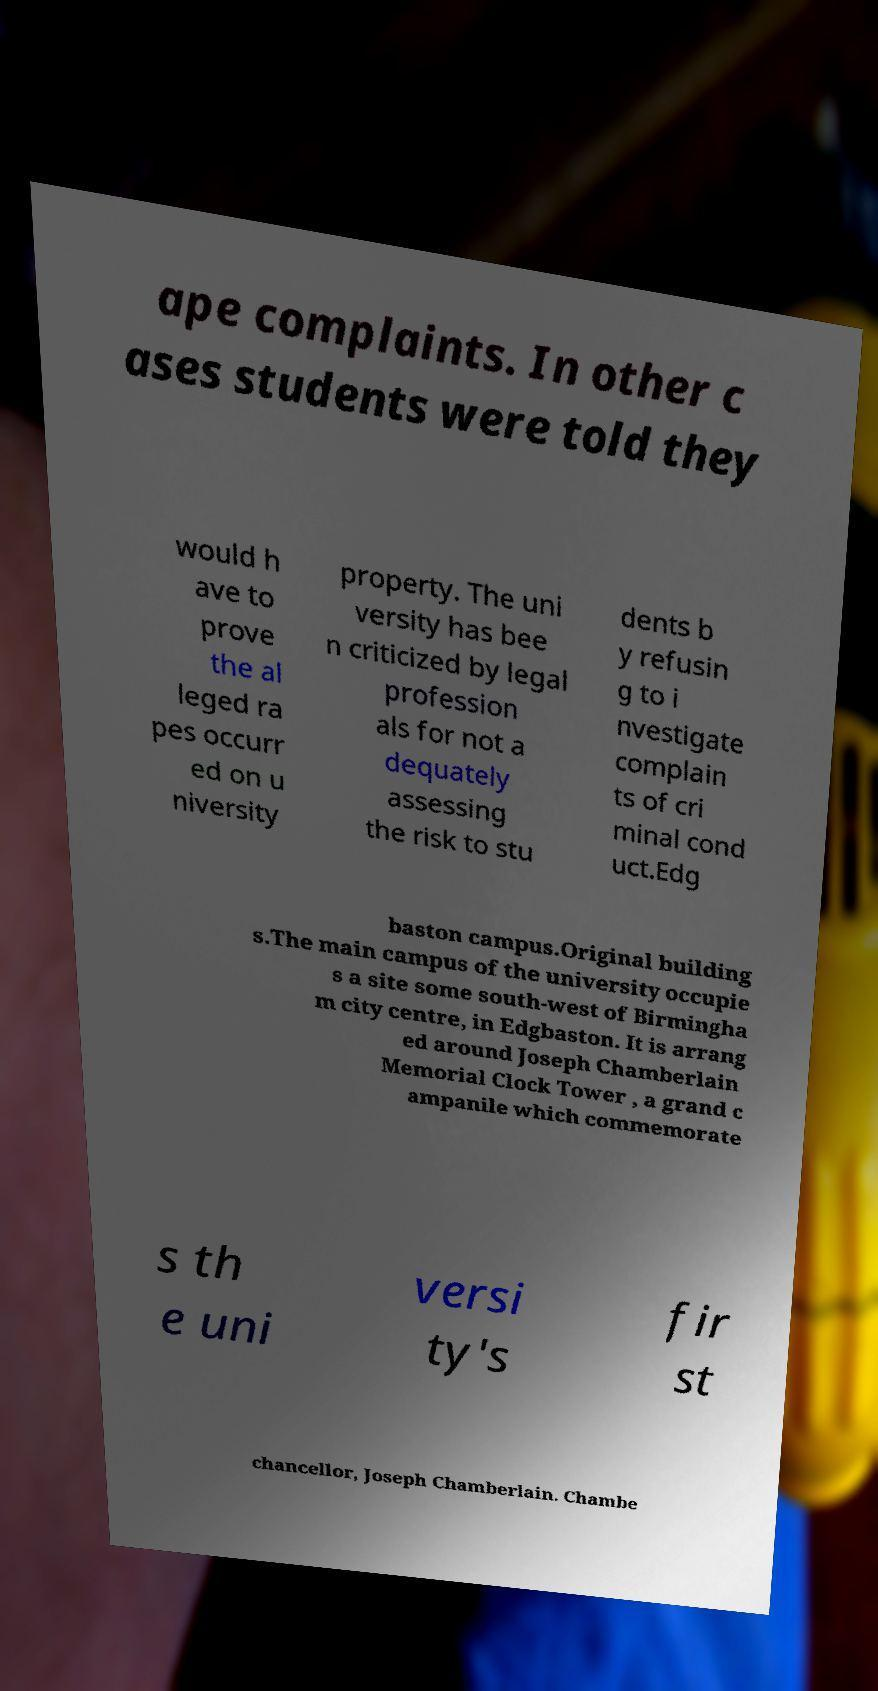Could you extract and type out the text from this image? ape complaints. In other c ases students were told they would h ave to prove the al leged ra pes occurr ed on u niversity property. The uni versity has bee n criticized by legal profession als for not a dequately assessing the risk to stu dents b y refusin g to i nvestigate complain ts of cri minal cond uct.Edg baston campus.Original building s.The main campus of the university occupie s a site some south-west of Birmingha m city centre, in Edgbaston. It is arrang ed around Joseph Chamberlain Memorial Clock Tower , a grand c ampanile which commemorate s th e uni versi ty's fir st chancellor, Joseph Chamberlain. Chambe 